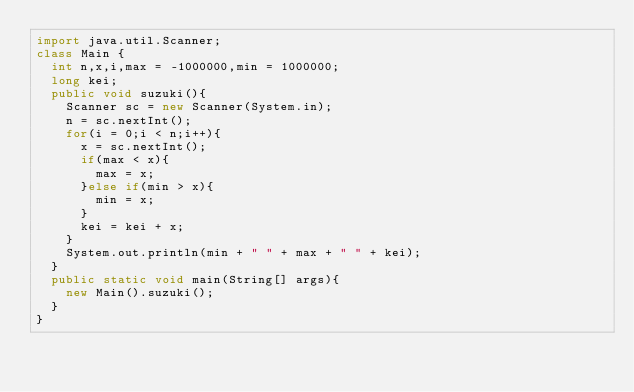<code> <loc_0><loc_0><loc_500><loc_500><_Java_>import java.util.Scanner;
class Main {
	int n,x,i,max = -1000000,min = 1000000;
	long kei;
	public void suzuki(){
		Scanner sc = new Scanner(System.in);
		n = sc.nextInt();
		for(i = 0;i < n;i++){
			x = sc.nextInt();
			if(max < x){
				max = x;
			}else if(min > x){
				min = x;
			}
			kei = kei + x;
		}
		System.out.println(min + " " + max + " " + kei);
	}
	public static void main(String[] args){
		new Main().suzuki();
	}
}</code> 